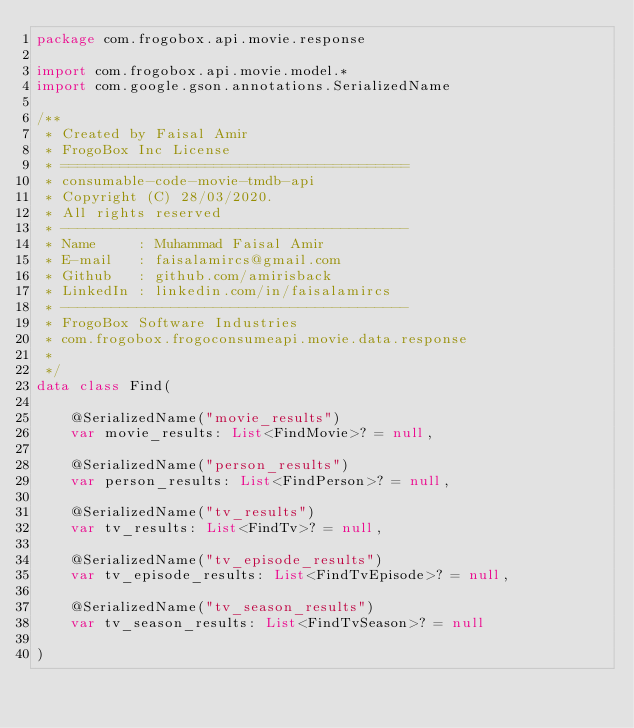<code> <loc_0><loc_0><loc_500><loc_500><_Kotlin_>package com.frogobox.api.movie.response

import com.frogobox.api.movie.model.*
import com.google.gson.annotations.SerializedName

/**
 * Created by Faisal Amir
 * FrogoBox Inc License
 * =========================================
 * consumable-code-movie-tmdb-api
 * Copyright (C) 28/03/2020.
 * All rights reserved
 * -----------------------------------------
 * Name     : Muhammad Faisal Amir
 * E-mail   : faisalamircs@gmail.com
 * Github   : github.com/amirisback
 * LinkedIn : linkedin.com/in/faisalamircs
 * -----------------------------------------
 * FrogoBox Software Industries
 * com.frogobox.frogoconsumeapi.movie.data.response
 *
 */
data class Find(

    @SerializedName("movie_results")
    var movie_results: List<FindMovie>? = null,

    @SerializedName("person_results")
    var person_results: List<FindPerson>? = null,

    @SerializedName("tv_results")
    var tv_results: List<FindTv>? = null,

    @SerializedName("tv_episode_results")
    var tv_episode_results: List<FindTvEpisode>? = null,

    @SerializedName("tv_season_results")
    var tv_season_results: List<FindTvSeason>? = null

)</code> 